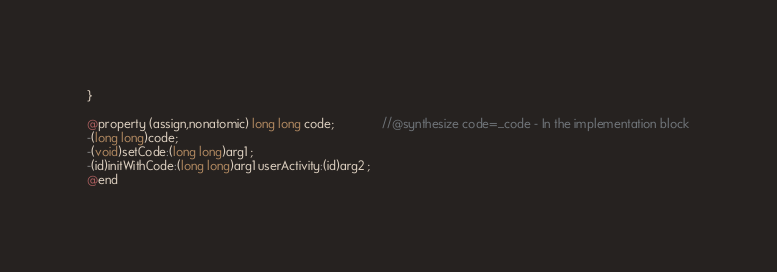Convert code to text. <code><loc_0><loc_0><loc_500><loc_500><_C_>
}

@property (assign,nonatomic) long long code;              //@synthesize code=_code - In the implementation block
-(long long)code;
-(void)setCode:(long long)arg1 ;
-(id)initWithCode:(long long)arg1 userActivity:(id)arg2 ;
@end

</code> 